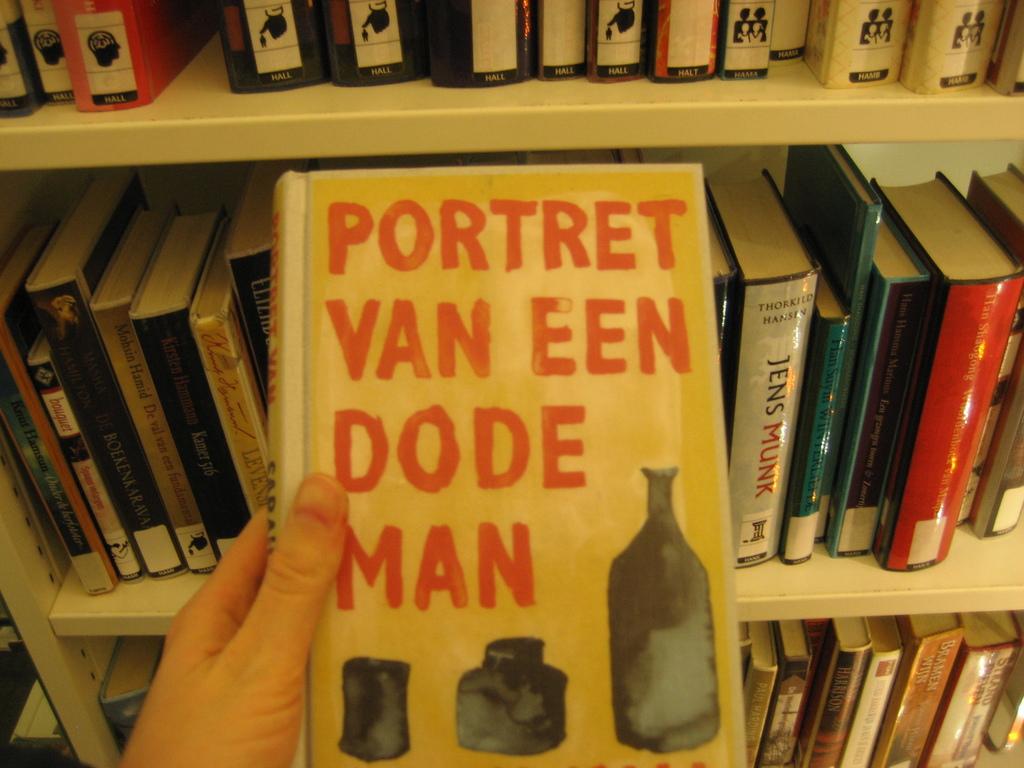What is the title of this book?
Your answer should be very brief. Portret van een dode man. Does one of the books say jens munk?
Provide a succinct answer. Yes. 